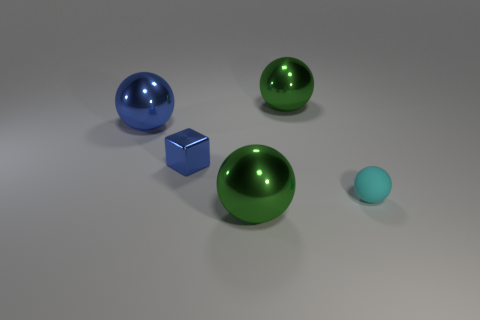How many other objects are the same material as the tiny ball? 0 